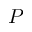Convert formula to latex. <formula><loc_0><loc_0><loc_500><loc_500>P</formula> 